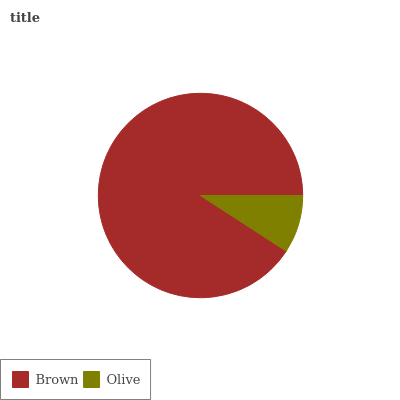Is Olive the minimum?
Answer yes or no. Yes. Is Brown the maximum?
Answer yes or no. Yes. Is Olive the maximum?
Answer yes or no. No. Is Brown greater than Olive?
Answer yes or no. Yes. Is Olive less than Brown?
Answer yes or no. Yes. Is Olive greater than Brown?
Answer yes or no. No. Is Brown less than Olive?
Answer yes or no. No. Is Brown the high median?
Answer yes or no. Yes. Is Olive the low median?
Answer yes or no. Yes. Is Olive the high median?
Answer yes or no. No. Is Brown the low median?
Answer yes or no. No. 